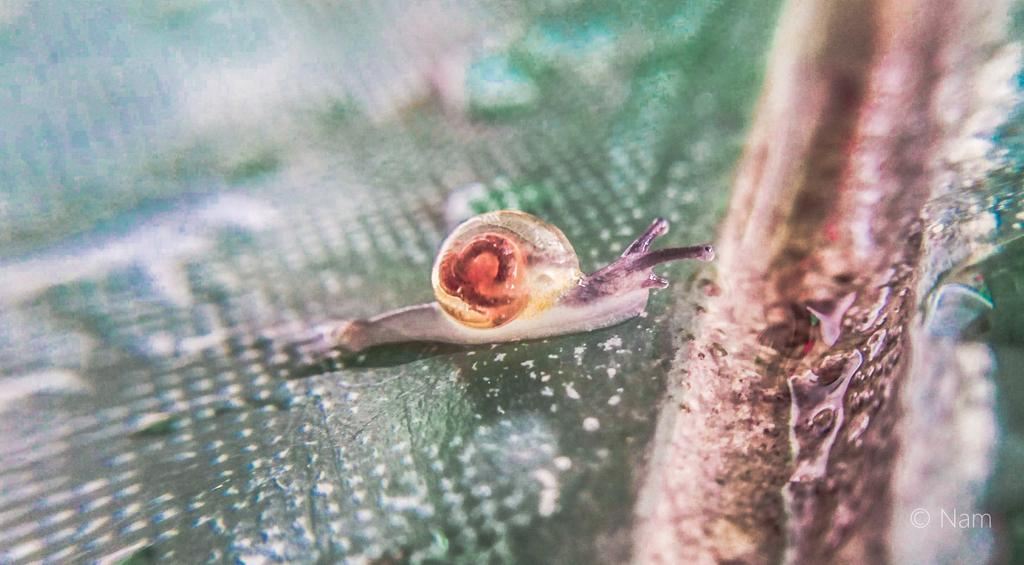What type of animal is in the image? There is a snail in the image. What is the snail resting on in the image? The snail is on a surface in the image. What type of grain can be seen in the image? There is no grain present in the image; it features a snail on a surface. What noise can be heard coming from the snail in the image? Snails do not make noise, so there is no noise to be heard from the snail in the image. 